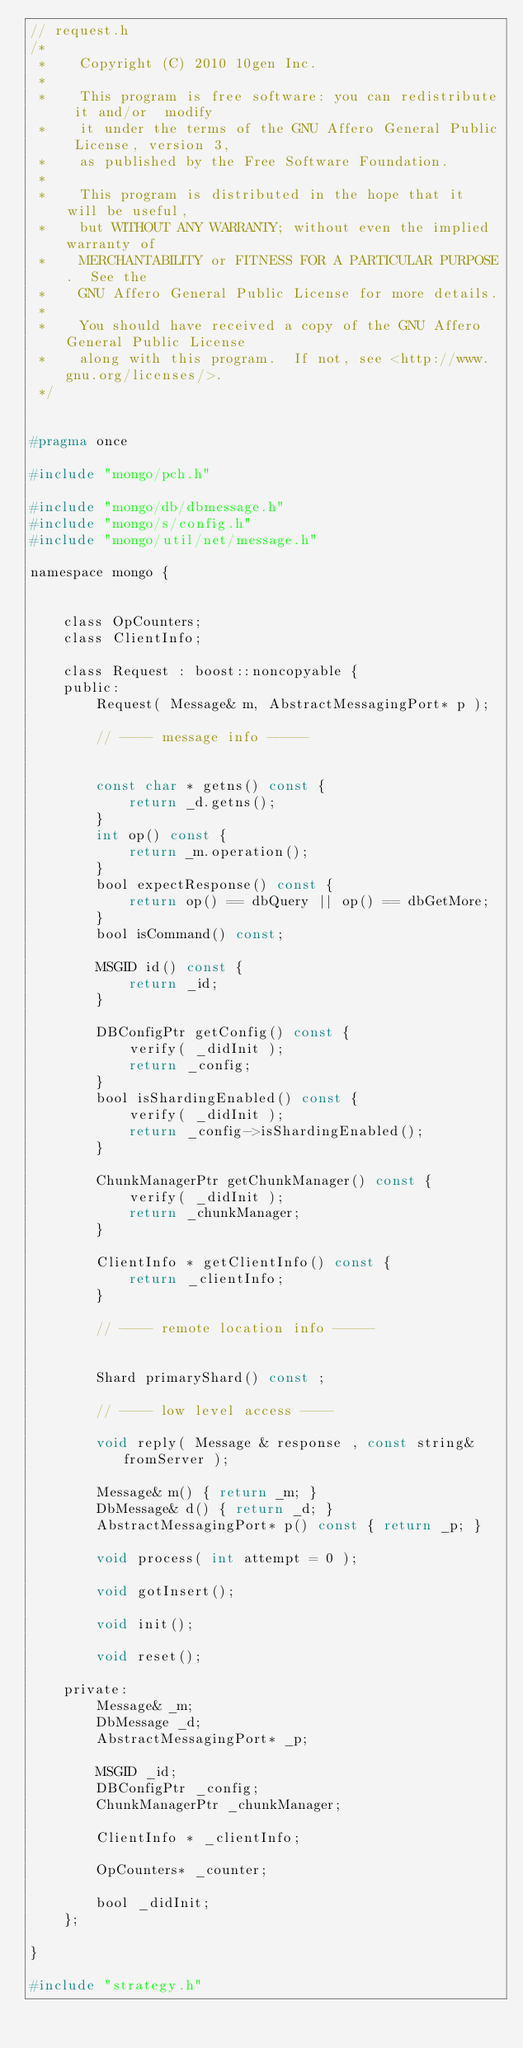<code> <loc_0><loc_0><loc_500><loc_500><_C_>// request.h
/*
 *    Copyright (C) 2010 10gen Inc.
 *
 *    This program is free software: you can redistribute it and/or  modify
 *    it under the terms of the GNU Affero General Public License, version 3,
 *    as published by the Free Software Foundation.
 *
 *    This program is distributed in the hope that it will be useful,
 *    but WITHOUT ANY WARRANTY; without even the implied warranty of
 *    MERCHANTABILITY or FITNESS FOR A PARTICULAR PURPOSE.  See the
 *    GNU Affero General Public License for more details.
 *
 *    You should have received a copy of the GNU Affero General Public License
 *    along with this program.  If not, see <http://www.gnu.org/licenses/>.
 */


#pragma once

#include "mongo/pch.h"

#include "mongo/db/dbmessage.h"
#include "mongo/s/config.h"
#include "mongo/util/net/message.h"

namespace mongo {


    class OpCounters;
    class ClientInfo;

    class Request : boost::noncopyable {
    public:
        Request( Message& m, AbstractMessagingPort* p );

        // ---- message info -----


        const char * getns() const {
            return _d.getns();
        }
        int op() const {
            return _m.operation();
        }
        bool expectResponse() const {
            return op() == dbQuery || op() == dbGetMore;
        }
        bool isCommand() const;

        MSGID id() const {
            return _id;
        }

        DBConfigPtr getConfig() const {
            verify( _didInit );
            return _config;
        }
        bool isShardingEnabled() const {
            verify( _didInit );
            return _config->isShardingEnabled();
        }

        ChunkManagerPtr getChunkManager() const {
            verify( _didInit );
            return _chunkManager;
        }

        ClientInfo * getClientInfo() const {
            return _clientInfo;
        }

        // ---- remote location info -----


        Shard primaryShard() const ;

        // ---- low level access ----

        void reply( Message & response , const string& fromServer );

        Message& m() { return _m; }
        DbMessage& d() { return _d; }
        AbstractMessagingPort* p() const { return _p; }

        void process( int attempt = 0 );

        void gotInsert();

        void init();

        void reset();

    private:
        Message& _m;
        DbMessage _d;
        AbstractMessagingPort* _p;

        MSGID _id;
        DBConfigPtr _config;
        ChunkManagerPtr _chunkManager;

        ClientInfo * _clientInfo;

        OpCounters* _counter;

        bool _didInit;
    };

}

#include "strategy.h"
</code> 